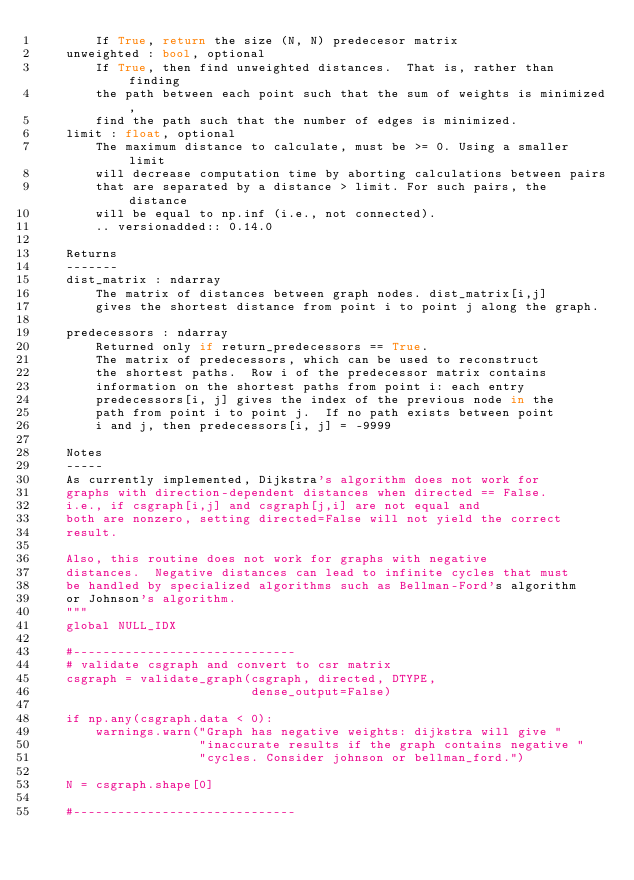Convert code to text. <code><loc_0><loc_0><loc_500><loc_500><_Cython_>        If True, return the size (N, N) predecesor matrix
    unweighted : bool, optional
        If True, then find unweighted distances.  That is, rather than finding
        the path between each point such that the sum of weights is minimized,
        find the path such that the number of edges is minimized.
    limit : float, optional
        The maximum distance to calculate, must be >= 0. Using a smaller limit
        will decrease computation time by aborting calculations between pairs
        that are separated by a distance > limit. For such pairs, the distance
        will be equal to np.inf (i.e., not connected).
        .. versionadded:: 0.14.0

    Returns
    -------
    dist_matrix : ndarray
        The matrix of distances between graph nodes. dist_matrix[i,j]
        gives the shortest distance from point i to point j along the graph.

    predecessors : ndarray
        Returned only if return_predecessors == True.
        The matrix of predecessors, which can be used to reconstruct
        the shortest paths.  Row i of the predecessor matrix contains
        information on the shortest paths from point i: each entry
        predecessors[i, j] gives the index of the previous node in the
        path from point i to point j.  If no path exists between point
        i and j, then predecessors[i, j] = -9999

    Notes
    -----
    As currently implemented, Dijkstra's algorithm does not work for
    graphs with direction-dependent distances when directed == False.
    i.e., if csgraph[i,j] and csgraph[j,i] are not equal and
    both are nonzero, setting directed=False will not yield the correct
    result.

    Also, this routine does not work for graphs with negative
    distances.  Negative distances can lead to infinite cycles that must
    be handled by specialized algorithms such as Bellman-Ford's algorithm
    or Johnson's algorithm.
    """
    global NULL_IDX

    #------------------------------
    # validate csgraph and convert to csr matrix
    csgraph = validate_graph(csgraph, directed, DTYPE,
                             dense_output=False)

    if np.any(csgraph.data < 0):
        warnings.warn("Graph has negative weights: dijkstra will give "
                      "inaccurate results if the graph contains negative "
                      "cycles. Consider johnson or bellman_ford.")

    N = csgraph.shape[0]

    #------------------------------</code> 